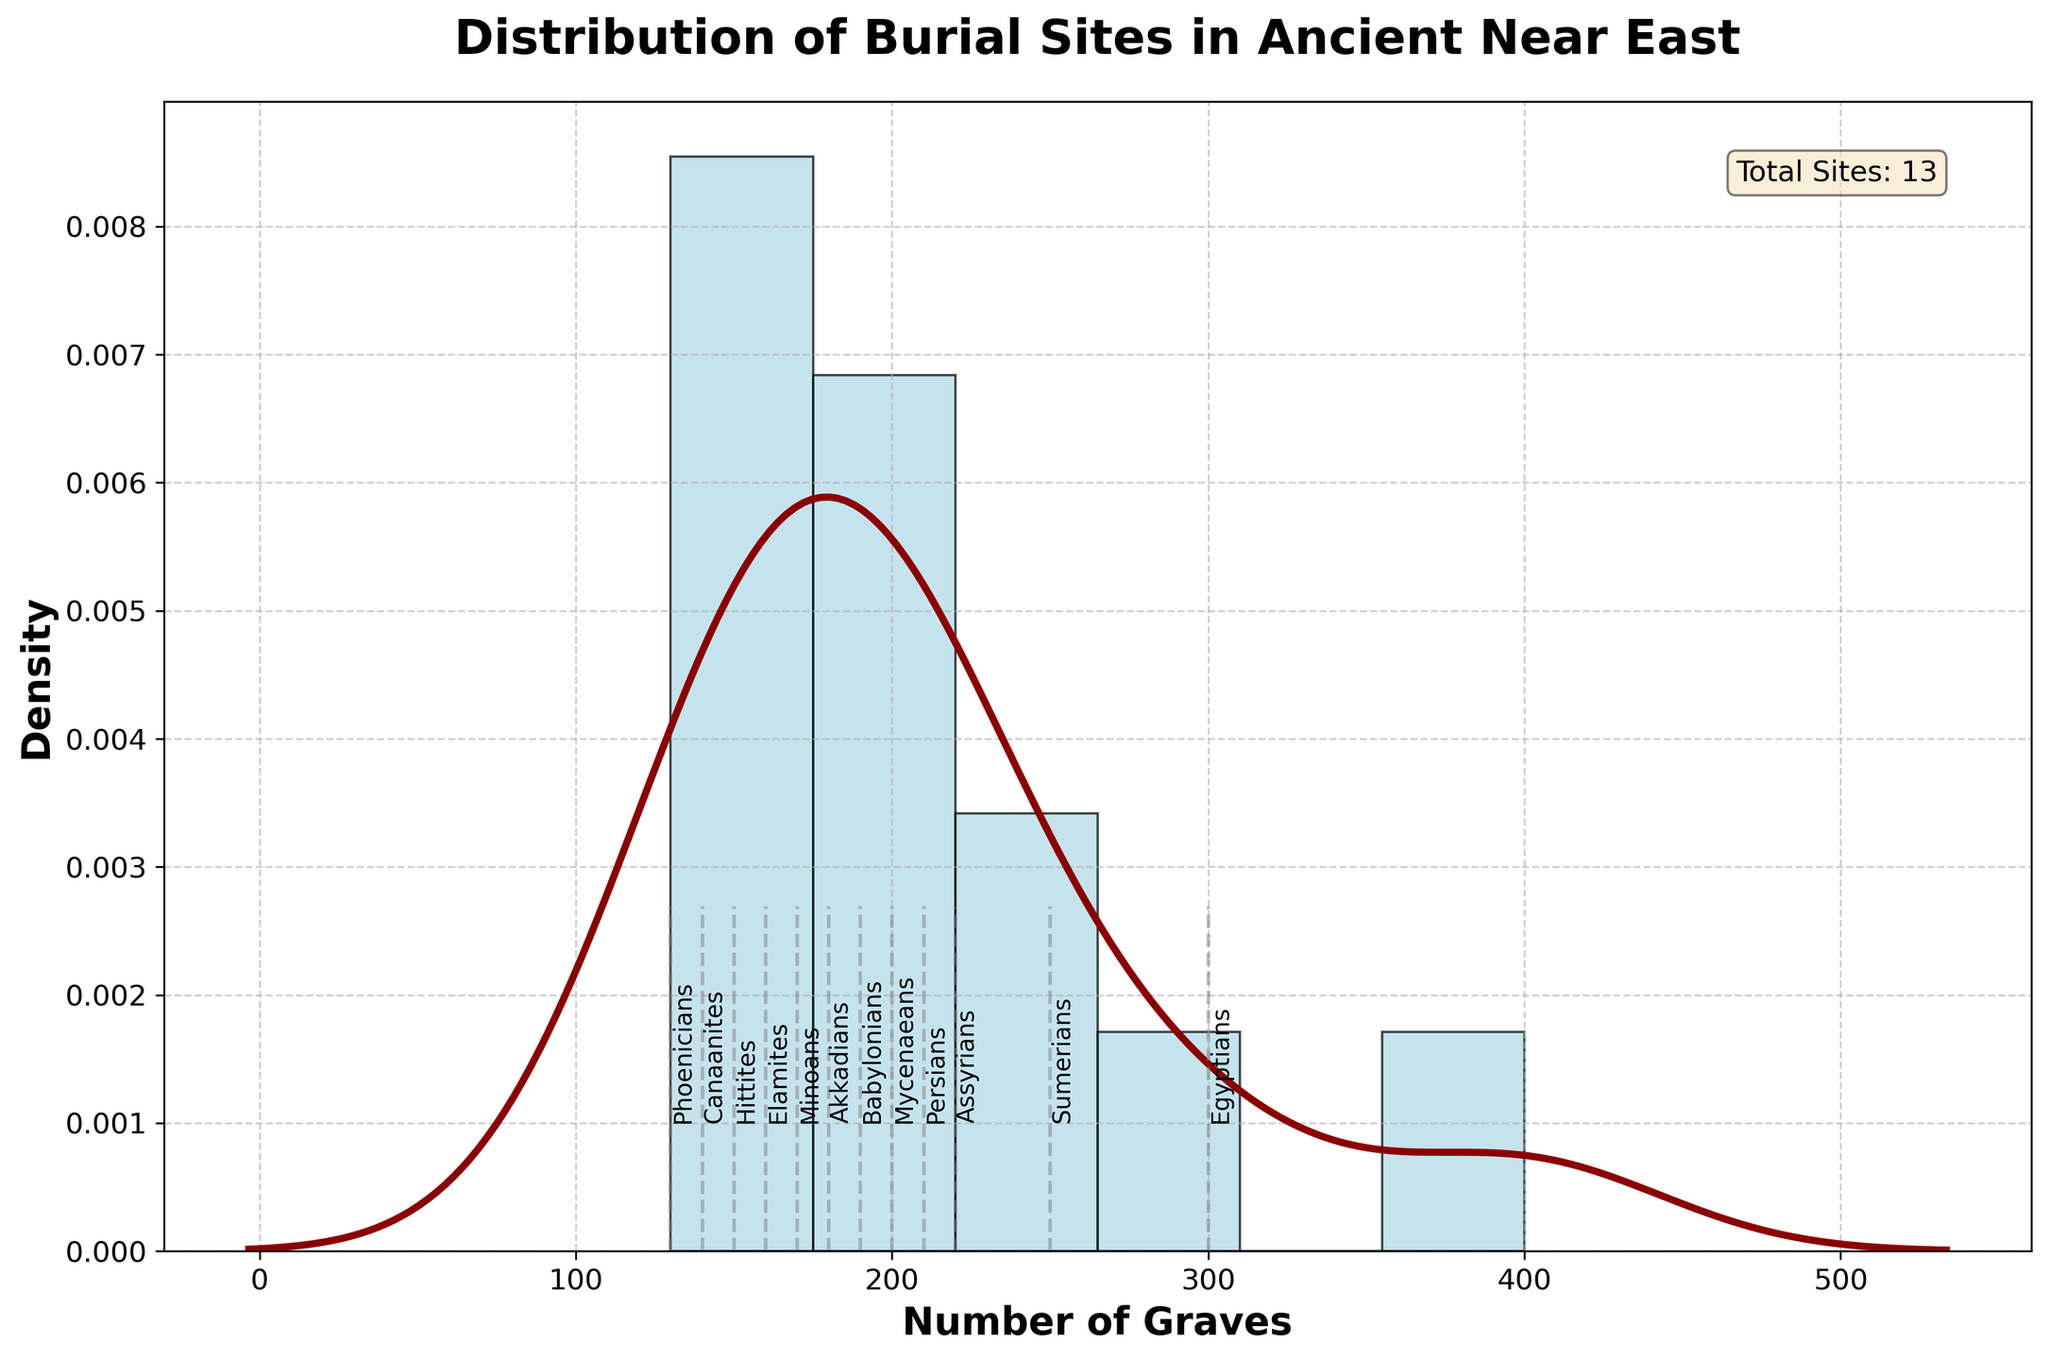What is the title of the figure? The title is displayed at the top of the figure, indicating what the plot represents.
Answer: Distribution of Burial Sites in Ancient Near East How many burial sites are represented in the figure? There is a text box on the figure that provides the total number of burial sites.
Answer: 13 What is the range of the number of graves depicted in the figure? The x-axis represents the number of graves, and you can see the range from the minimum to the maximum value shown.
Answer: 130 to 400 Which burial site has the highest number of graves? By examining the labeled lines on the x-axis, you can identify the burial site with the highest number of graves.
Answer: Valley of the Kings Which region has the burial site with the lowest number of graves? Look for the burial site with the lowest number of graves and check the corresponding region mentioned along with it.
Answer: Levant (Byblos) How many burial sites have more than 200 graves? By observing the labeled lines on the x-axis, count the number of burial sites with a number of graves greater than 200.
Answer: 6 What is the median number of graves across all burial sites? The median can be approximated by examining the central tendency of the distribution, located near the peak of the curve.
Answer: About 190-200 Which civilization has the burial site with 250 graves? Examine the labeled lines on the x-axis to find the burial site with 250 graves and then read its corresponding civilization.
Answer: Sumerians How does the number of graves in Persepolis compare to those in Nineveh? Identify the number of graves for both Persepolis and Nineveh from the labeled lines, then compare the values.
Answer: Persepolis has fewer graves than Nineveh What can you infer about the burial practices of the Egyptians compared to other civilizations in the dataset? Egyptians have two high counts, indicating possibly more extensive or large-scale burial practices compared to other civilizations.
Answer: Egyptians had larger burial sites 